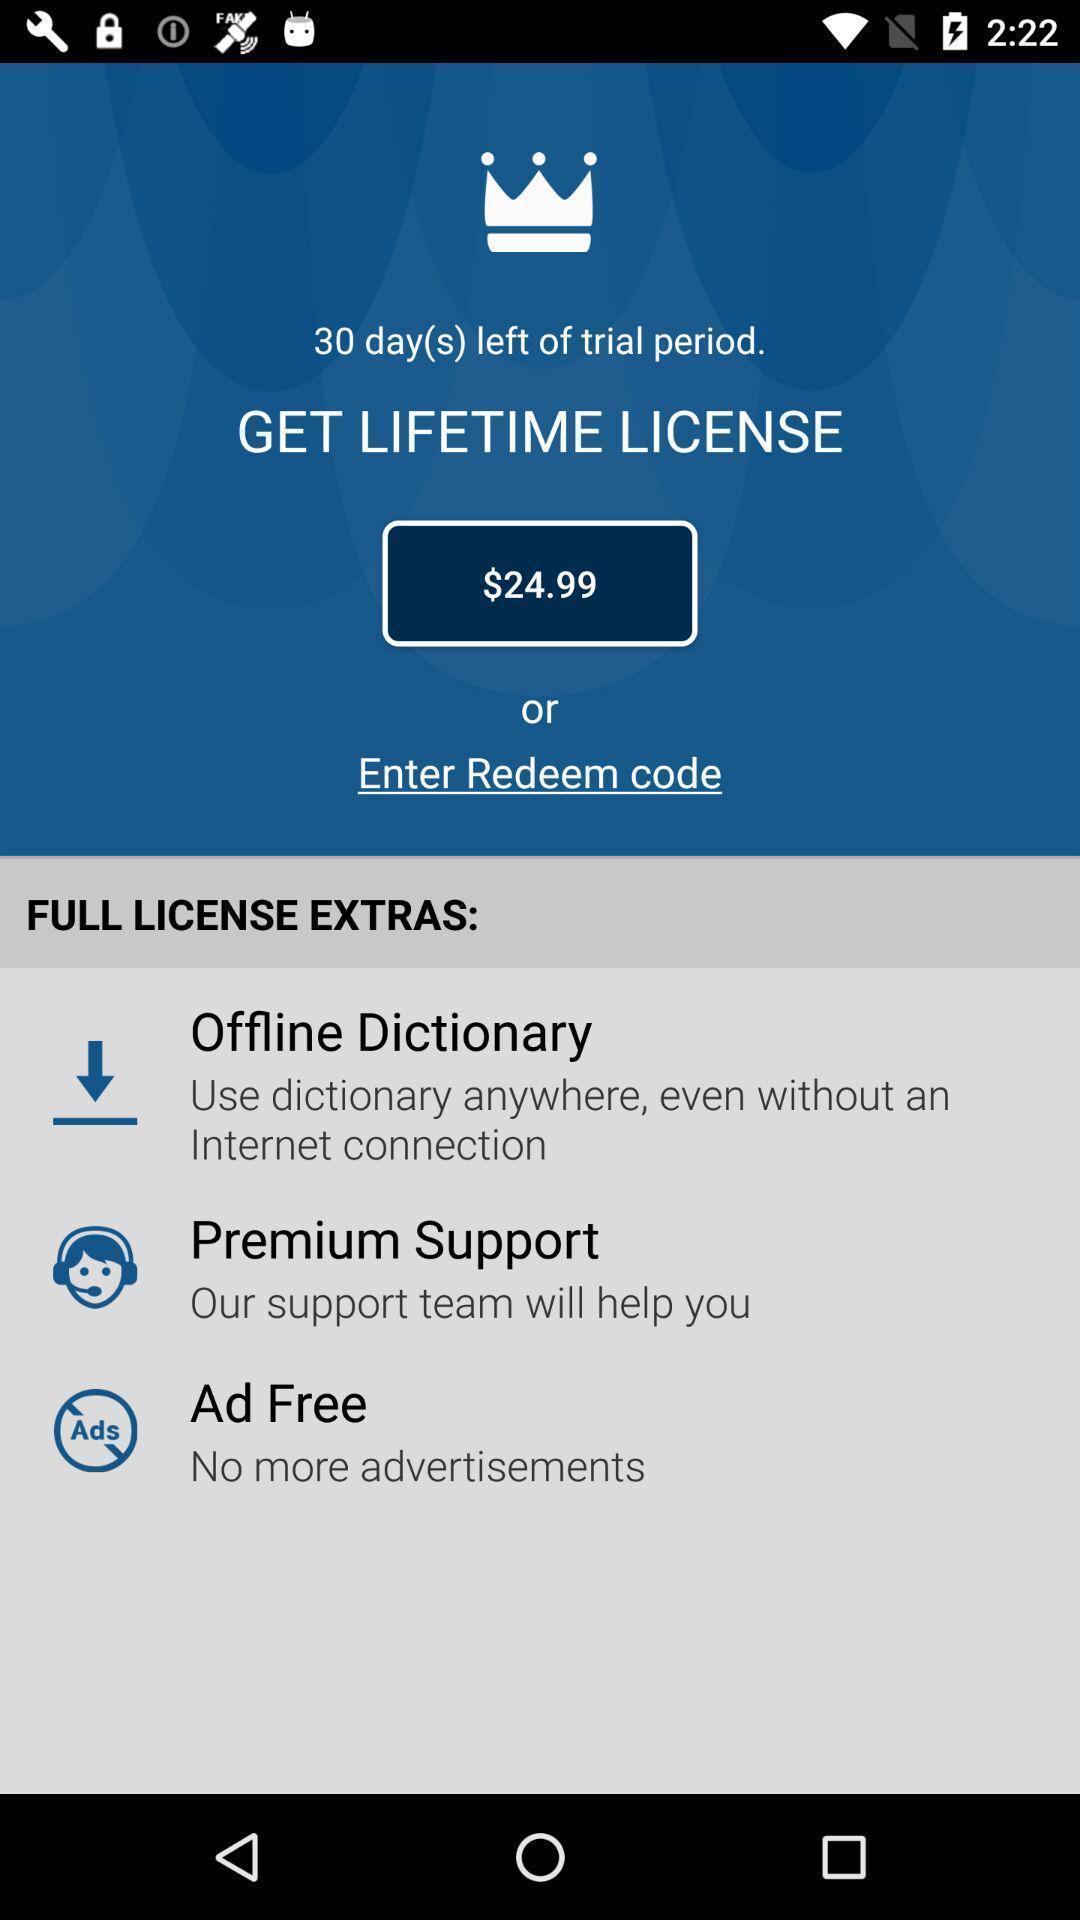Describe the key features of this screenshot. Page to get license in the dictionary app. 